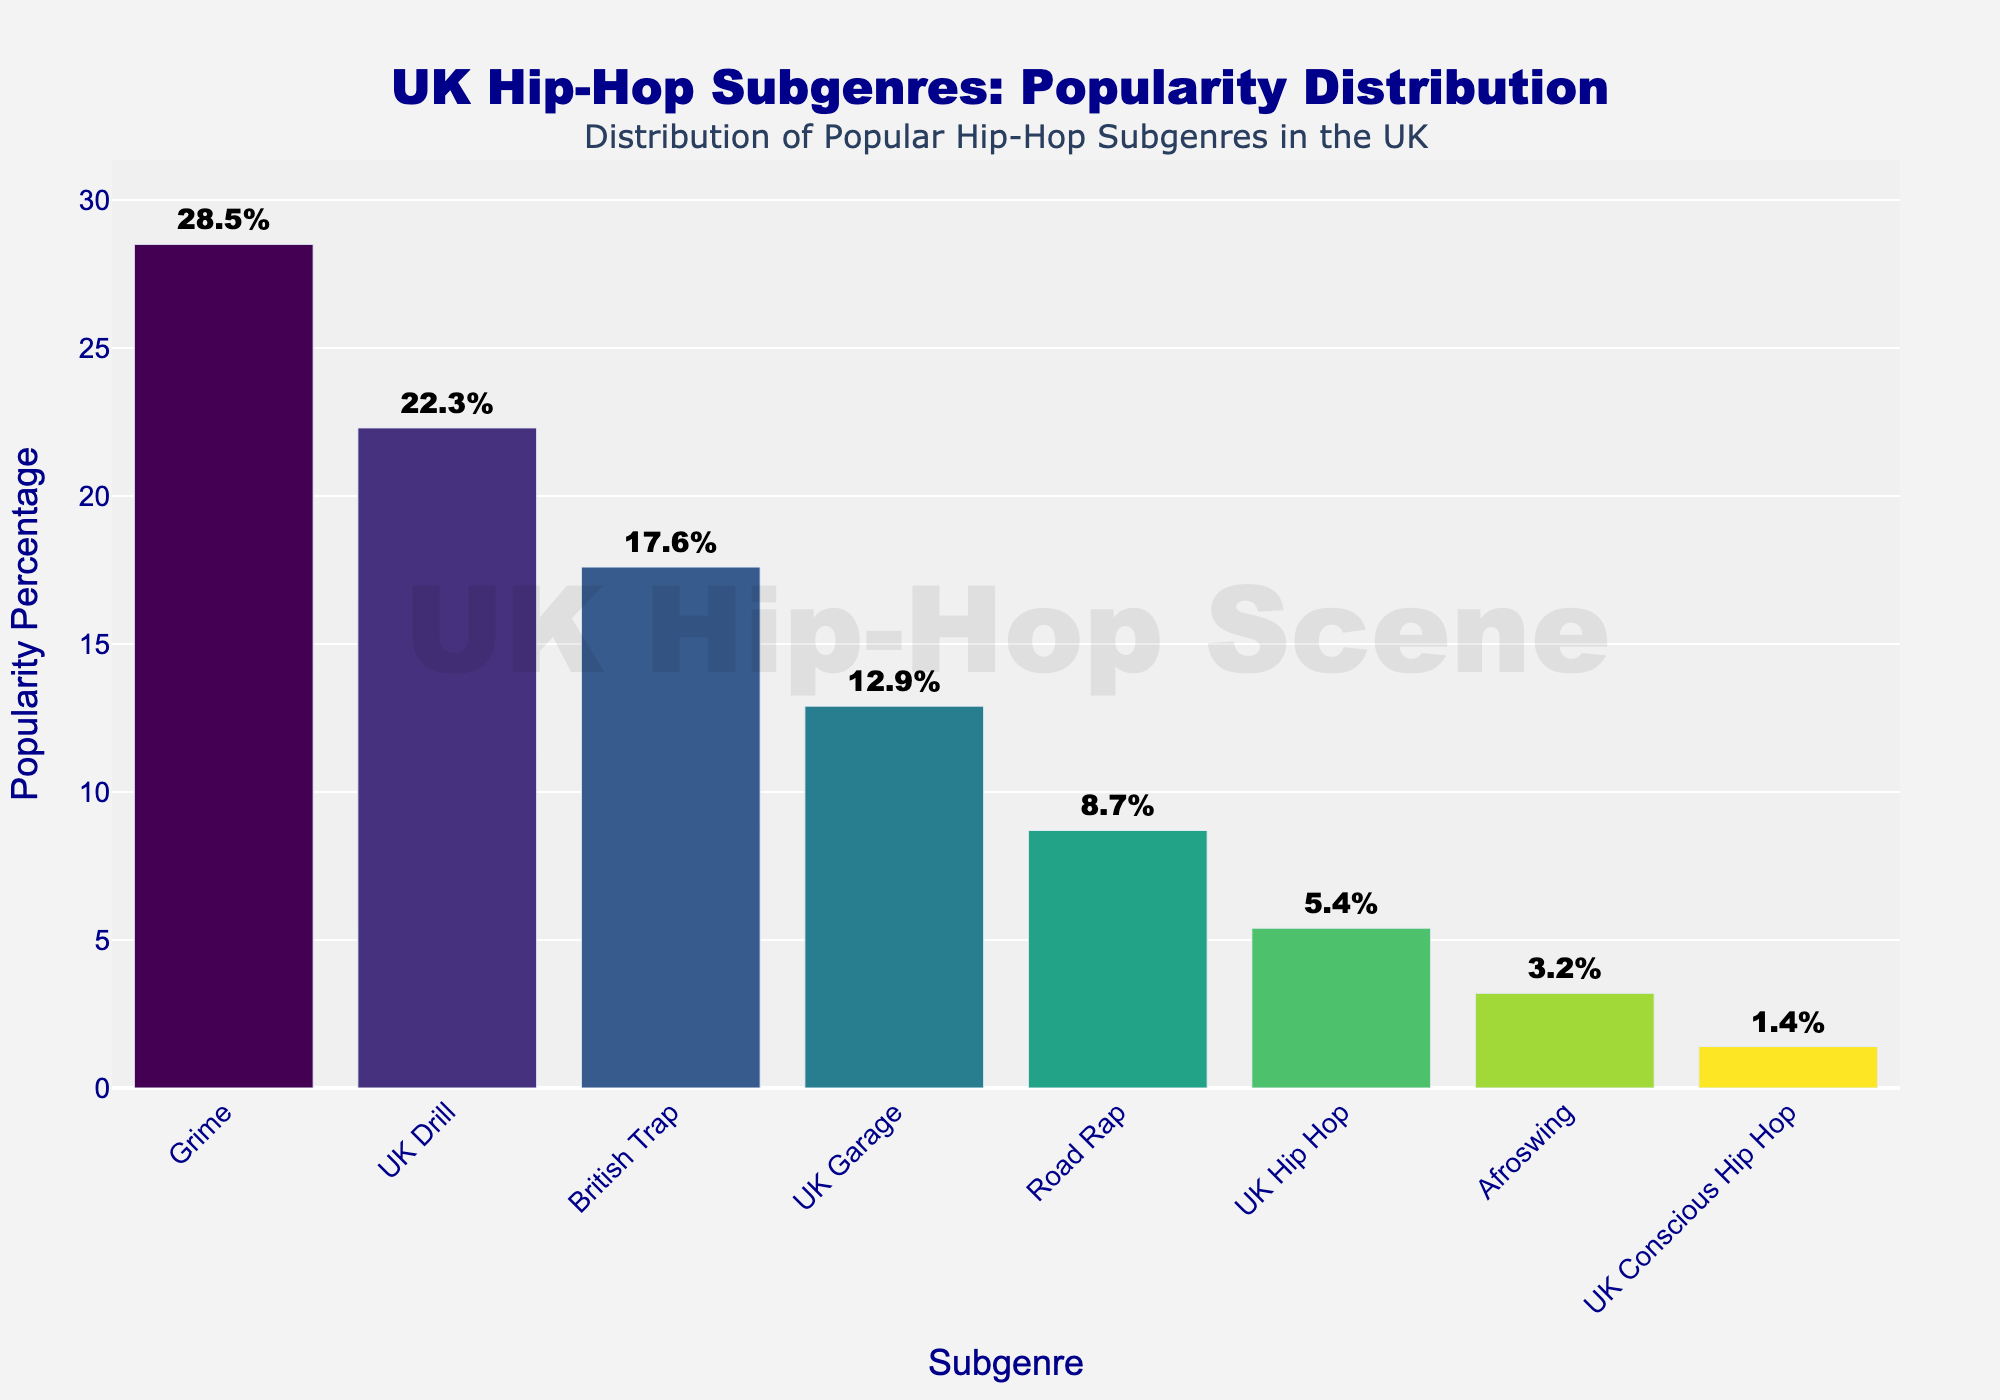What is the most popular hip-hop subgenre in the UK music scene? Look at the bar with the greatest height on the chart. The subgenre with the highest bar represents the most popular subgenre.
Answer: Grime Which subgenre holds the second-highest popularity percentage? Identify the bar with the second highest height, which corresponds to the second highest popularity percentage.
Answer: UK Drill How much more popular is Grime compared to UK Hip Hop? Find the popularity percentage of Grime and UK Hip Hop, then subtract the percentage of UK Hip Hop from that of Grime. Grime has 28.5% and UK Hip Hop has 5.4%, so 28.5% - 5.4% = 23.1%.
Answer: 23.1% What is the combined popularity percentage of British Trap and UK Garage? Add the popularity percentages of British Trap and UK Garage. British Trap is 17.6% and UK Garage is 12.9%, so 17.6% + 12.9% = 30.5%.
Answer: 30.5% How many subgenres have a popularity percentage greater than 15%? Identify and count the bars with a height representing more than 15% popularity. These subgenres are Grime (28.5%), UK Drill (22.3%), and British Trap (17.6%).
Answer: 3 Which subgenre has a lower popularity percentage: Road Rap or Afroswing? Compare the heights of the bars for Road Rap and Afroswing. Road Rap has a popularity of 8.7% and Afroswing has 3.2%.
Answer: Afroswing What is the difference in popularity between UK Garage and Road Rap? Subtract the popularity percentage of Road Rap from that of UK Garage. UK Garage has 12.9% and Road Rap has 8.7%, so 12.9% - 8.7% = 4.2%.
Answer: 4.2% What is the average popularity percentage of Grime, UK Drill, and British Trap? Add the popularity percentages of Grime, UK Drill, and British Trap and divide by 3. Grime is 28.5%, UK Drill is 22.3%, and British Trap is 17.6%. Average = (28.5 + 22.3 + 17.6) / 3 = 22.8%.
Answer: 22.8% If you combine the popularity percentages of UK Hip Hop, Afroswing, and UK Conscious Hip Hop, does it exceed the popularity of UK Drill? Calculate the combined popularity of UK Hip Hop, Afroswing, and UK Conscious Hip Hop, then compare it to UK Drill. UK Hip Hop is 5.4%, Afroswing is 3.2%, and UK Conscious Hip Hop is 1.4%. Combined = 5.4 + 3.2 + 1.4 = 10%. UK Drill is 22.3%.
Answer: No 